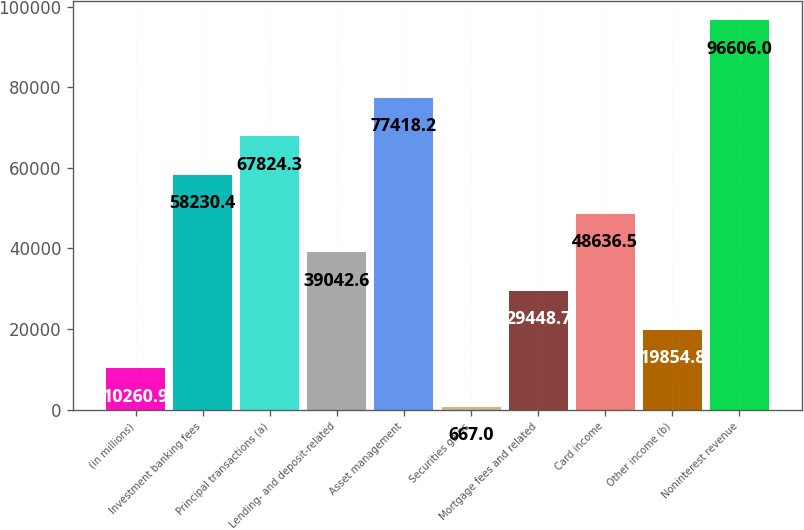<chart> <loc_0><loc_0><loc_500><loc_500><bar_chart><fcel>(in millions)<fcel>Investment banking fees<fcel>Principal transactions (a)<fcel>Lending- and deposit-related<fcel>Asset management<fcel>Securities gains<fcel>Mortgage fees and related<fcel>Card income<fcel>Other income (b)<fcel>Noninterest revenue<nl><fcel>10260.9<fcel>58230.4<fcel>67824.3<fcel>39042.6<fcel>77418.2<fcel>667<fcel>29448.7<fcel>48636.5<fcel>19854.8<fcel>96606<nl></chart> 